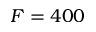Convert formula to latex. <formula><loc_0><loc_0><loc_500><loc_500>F = 4 0 0</formula> 